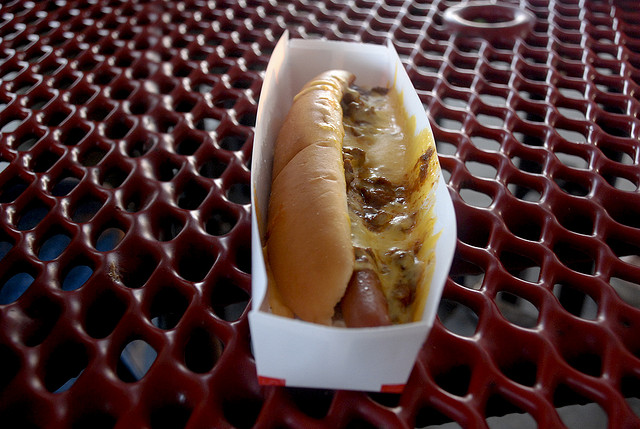Could you suggest a beverage that would pair well with this hot dog? A classic beverage pairing with a cheesy hot dog would be a cold soda or beer, depending on personal preference and the time of day. The carbonation can help cleanse the palate between bites. 